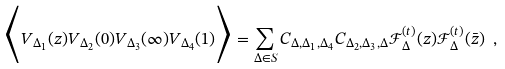<formula> <loc_0><loc_0><loc_500><loc_500>\Big < V _ { \Delta _ { 1 } } ( z ) V _ { \Delta _ { 2 } } ( 0 ) V _ { \Delta _ { 3 } } ( \infty ) V _ { \Delta _ { 4 } } ( 1 ) \Big > = \sum _ { \Delta \in S } C _ { \Delta , \Delta _ { 1 } , \Delta _ { 4 } } C _ { \Delta _ { 2 } , \Delta _ { 3 } , \Delta } \mathcal { F } ^ { ( t ) } _ { \Delta } ( z ) \mathcal { F } ^ { ( t ) } _ { \Delta } ( \bar { z } ) \ ,</formula> 